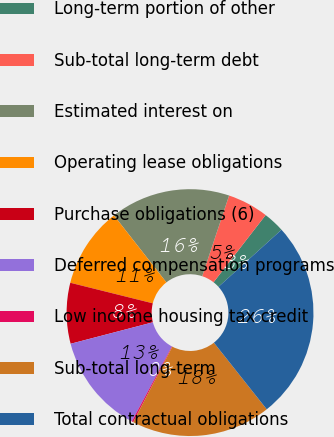<chart> <loc_0><loc_0><loc_500><loc_500><pie_chart><fcel>Long-term portion of other<fcel>Sub-total long-term debt<fcel>Estimated interest on<fcel>Operating lease obligations<fcel>Purchase obligations (6)<fcel>Deferred compensation programs<fcel>Low income housing tax credit<fcel>Sub-total long-term<fcel>Total contractual obligations<nl><fcel>2.79%<fcel>5.37%<fcel>15.7%<fcel>10.54%<fcel>7.95%<fcel>13.12%<fcel>0.2%<fcel>18.29%<fcel>26.04%<nl></chart> 